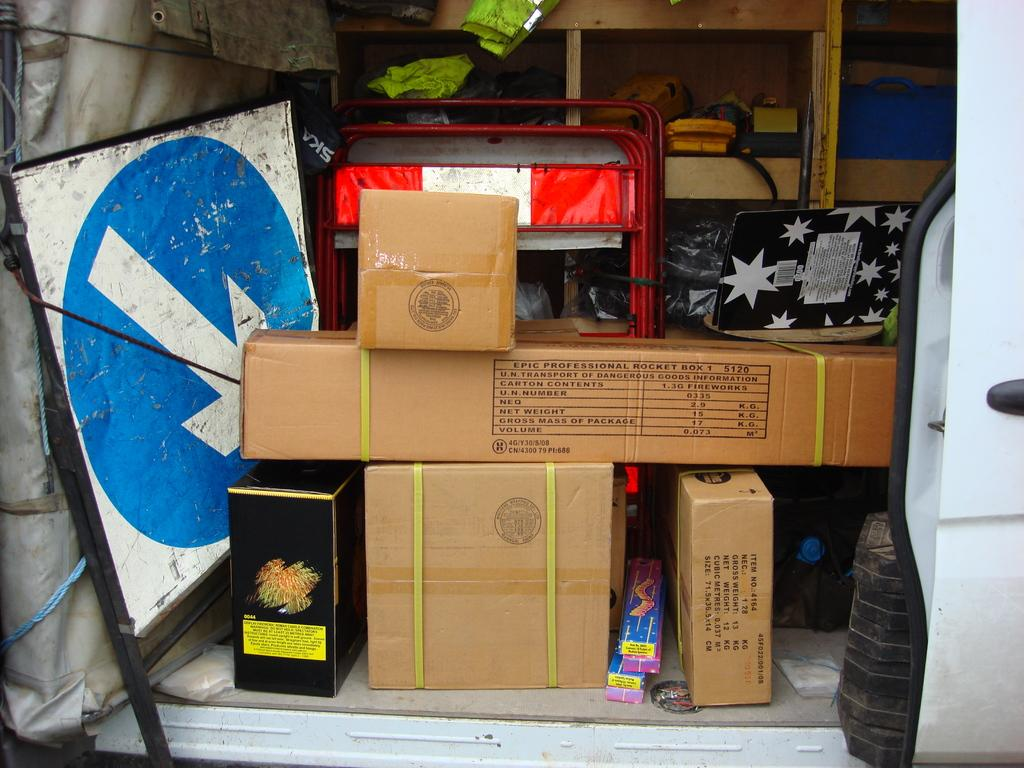What is the main subject of the image? There is a vehicle in the image. Can you describe the interior of the vehicle? There are many objects placed inside the vehicle. What type of can is visible inside the vehicle? There is no can visible inside the vehicle; the image only mentions that there are many objects placed inside. 